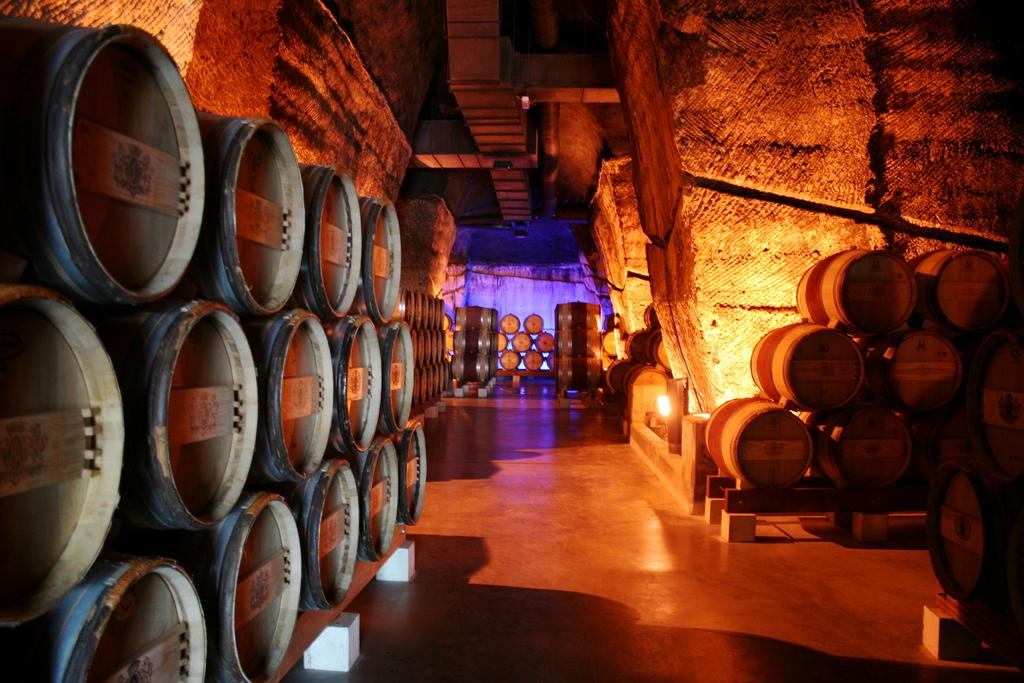What objects are arranged in rows in the image? There are barrels arranged in rows in the image. How are the barrels positioned in relation to each other? The barrels are arranged in rows in the image. What might be the purpose of arranging the barrels in this manner? It is not explicitly stated in the image, but the arrangement of barrels in rows might suggest storage or organization. Can you see any airplanes taking off or landing at the airport in the image? There is no airport or airplanes present in the image; it features barrels arranged in rows. What type of pollution is visible in the image? There is no pollution visible in the image; it only shows barrels arranged in rows. 